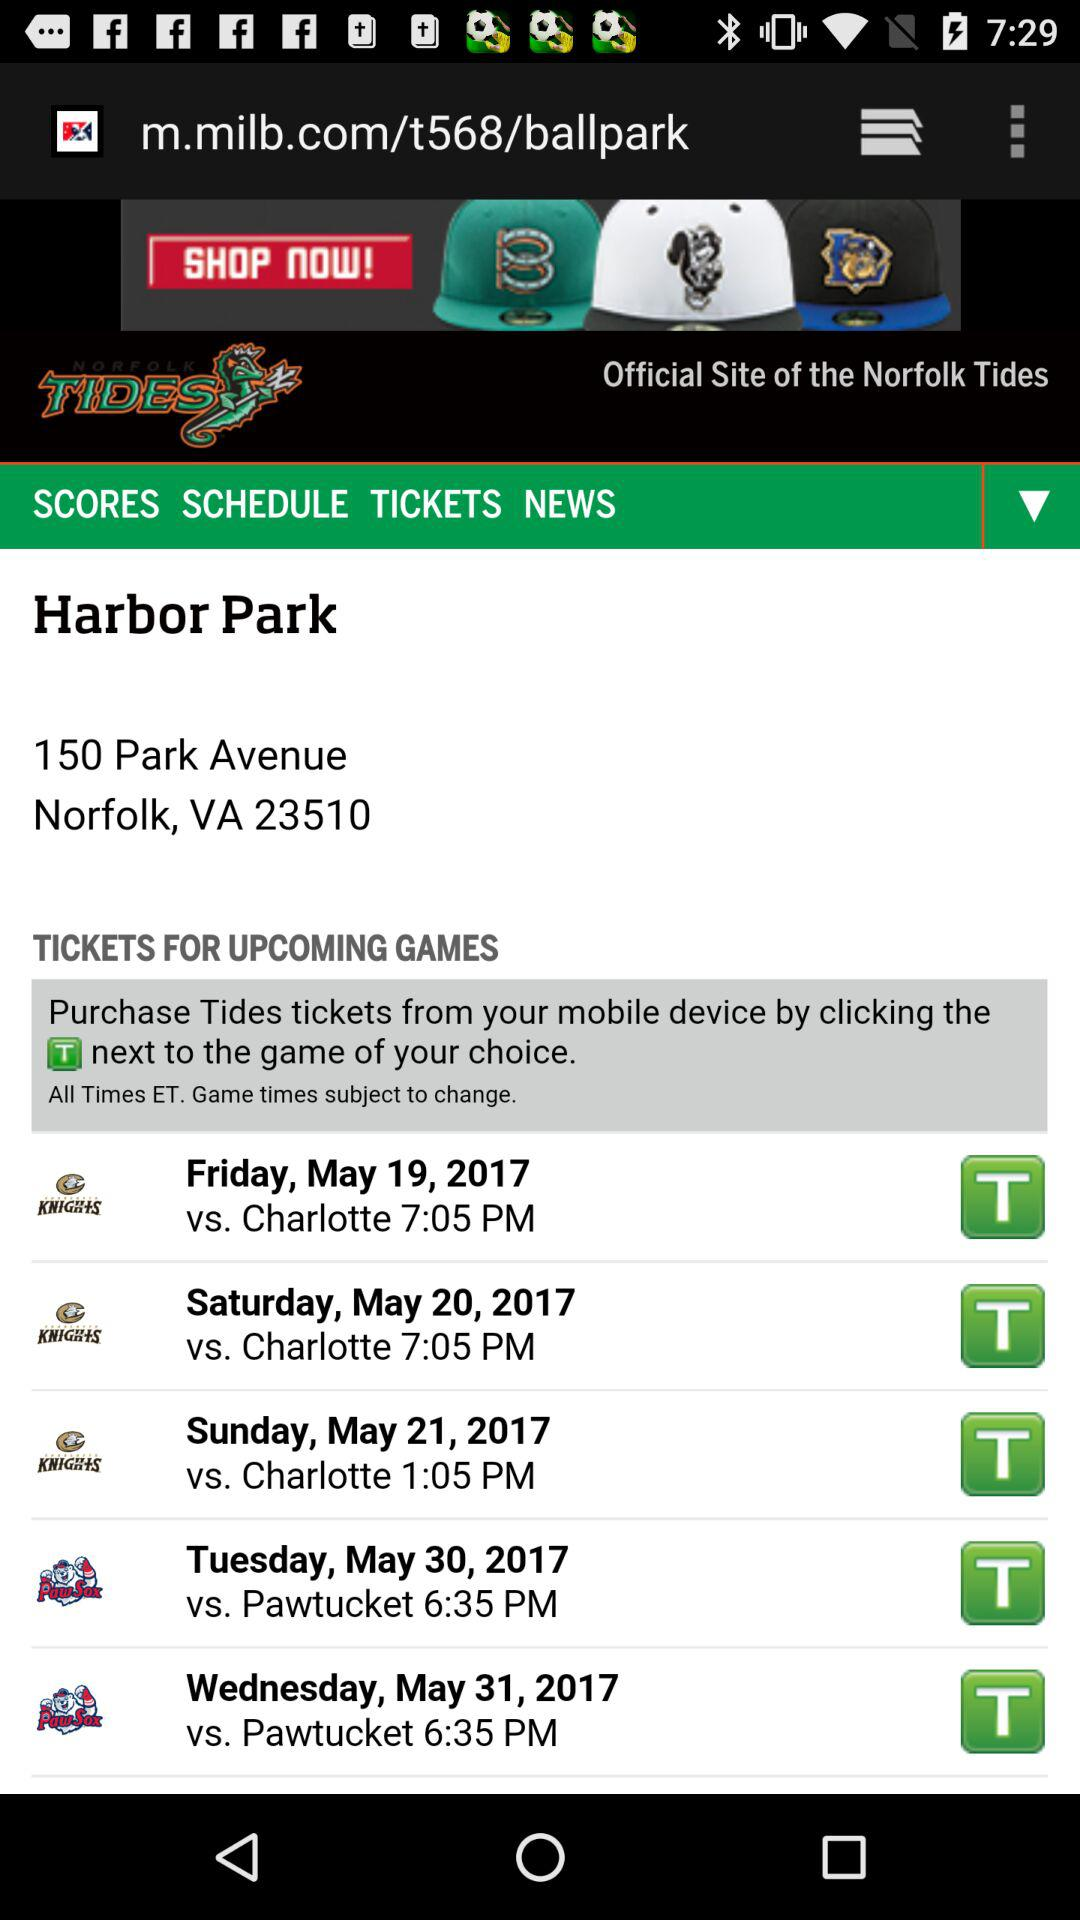What day falls on May 21, 2017? The day is Sunday. 